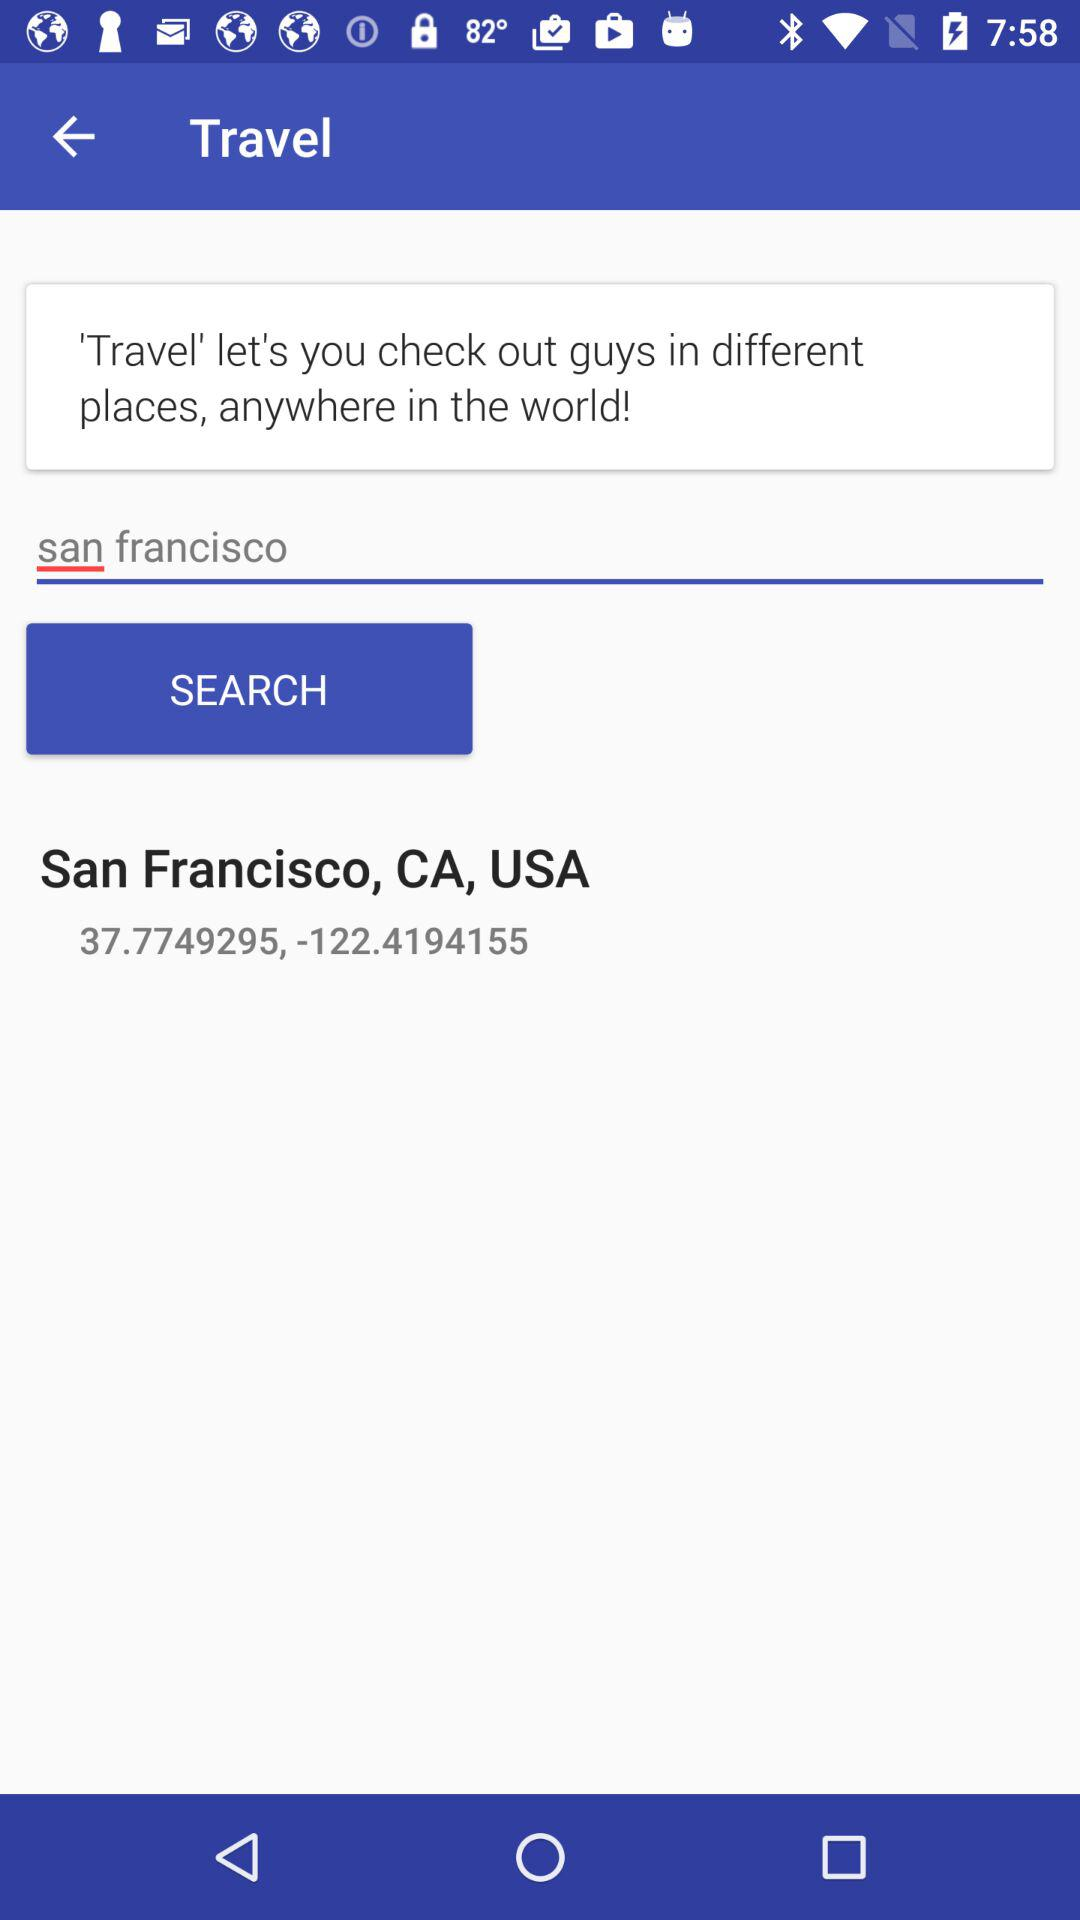What is the contact number?
When the provided information is insufficient, respond with <no answer>. <no answer> 